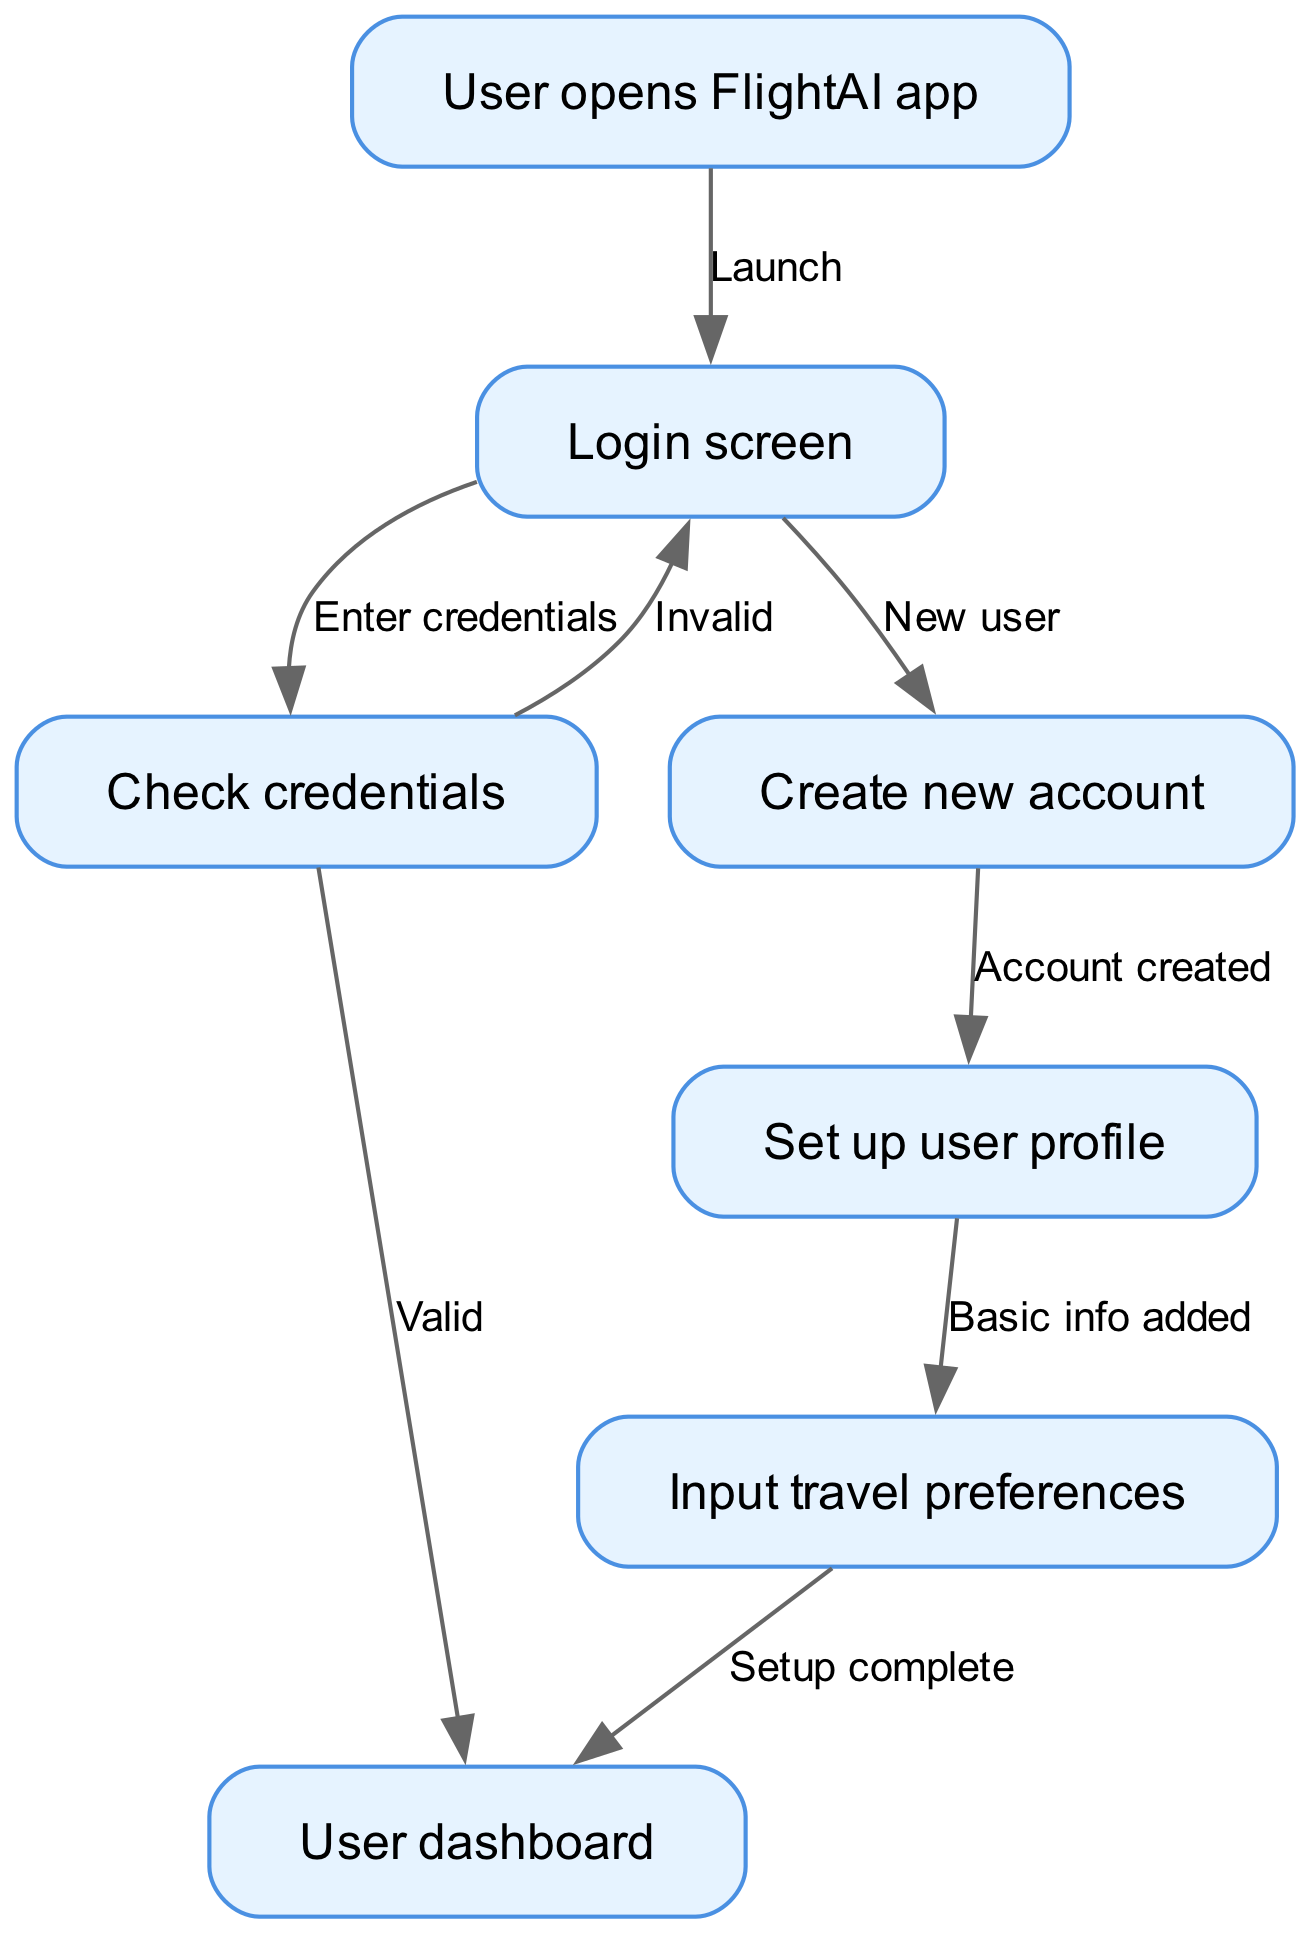What is the first node in the flow? The first node is indicated by the flow chart's starting point, labeled as "User opens FlightAI app."
Answer: User opens FlightAI app How many edges are in the diagram? Each edge connects two nodes, and there are 8 edges listed in the data.
Answer: 8 What action occurs after 'Check credentials' if they are valid? If the credentials are valid, the flow moves to the 'User dashboard' node.
Answer: User dashboard What does the 'Create new account' node lead to? After the 'Create new account' node, the next step in the flow is to 'Set up user profile.'
Answer: Set up user profile What happens if the credentials entered in 'Check credentials' are invalid? If the credentials are invalid, the flow returns to the 'Login screen' for another attempt at entering them.
Answer: Login screen What node follows 'Input travel preferences'? The node that comes after 'Input travel preferences' is 'User dashboard.'
Answer: User dashboard How does a user get to the 'Set up user profile' node? The user reaches 'Set up user profile' by successfully creating a new account after the 'Create new account' node.
Answer: Create new account What step is required before a user can access the 'User dashboard'? Before accessing the 'User dashboard', the user must have their credentials checked and validated, or must complete their profile setup including inputting preferences.
Answer: Check credentials, Set up user profile 